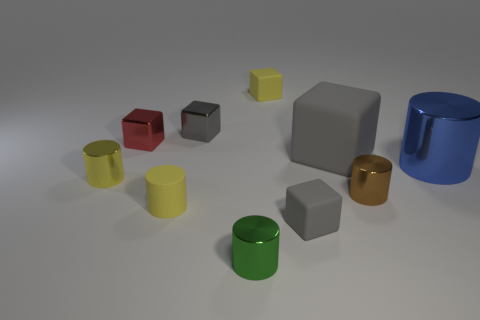How many gray cubes must be subtracted to get 1 gray cubes? 2 Subtract all large blue cylinders. How many cylinders are left? 4 Subtract all blue cylinders. How many cylinders are left? 4 Subtract 5 cylinders. How many cylinders are left? 0 Subtract all cyan cubes. Subtract all brown cylinders. How many cubes are left? 5 Subtract all green cubes. How many yellow cylinders are left? 2 Subtract all yellow things. Subtract all large purple things. How many objects are left? 7 Add 5 red metallic things. How many red metallic things are left? 6 Add 3 yellow cylinders. How many yellow cylinders exist? 5 Subtract 0 brown balls. How many objects are left? 10 